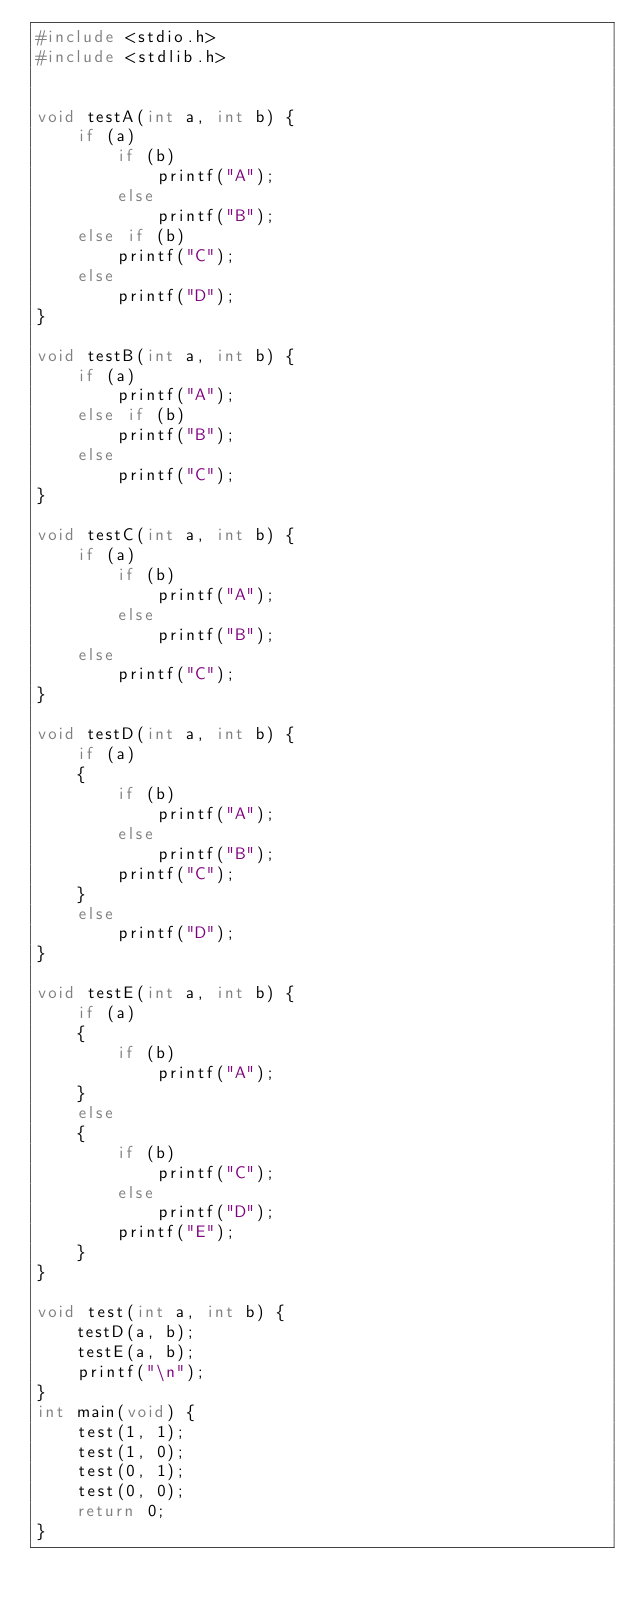Convert code to text. <code><loc_0><loc_0><loc_500><loc_500><_C_>#include <stdio.h>
#include <stdlib.h>


void testA(int a, int b) {
    if (a)
        if (b)
            printf("A");
        else
            printf("B");
    else if (b)
        printf("C");
    else
        printf("D");
}

void testB(int a, int b) {
    if (a)
        printf("A");
    else if (b)
        printf("B");
    else
        printf("C");
}

void testC(int a, int b) {
    if (a)
        if (b)
            printf("A");
        else
            printf("B");
    else
        printf("C");
}

void testD(int a, int b) {
    if (a)
    {
        if (b)
            printf("A");
        else
            printf("B");
        printf("C");
    }
    else
        printf("D");
}

void testE(int a, int b) {
    if (a)
    {
        if (b)
            printf("A");
    }
    else
    {
        if (b)
            printf("C");
        else
            printf("D");
        printf("E");
    }
}

void test(int a, int b) {
    testD(a, b);
    testE(a, b);
    printf("\n");
}
int main(void) {
    test(1, 1);
    test(1, 0);
    test(0, 1);
    test(0, 0);
    return 0;
}


</code> 